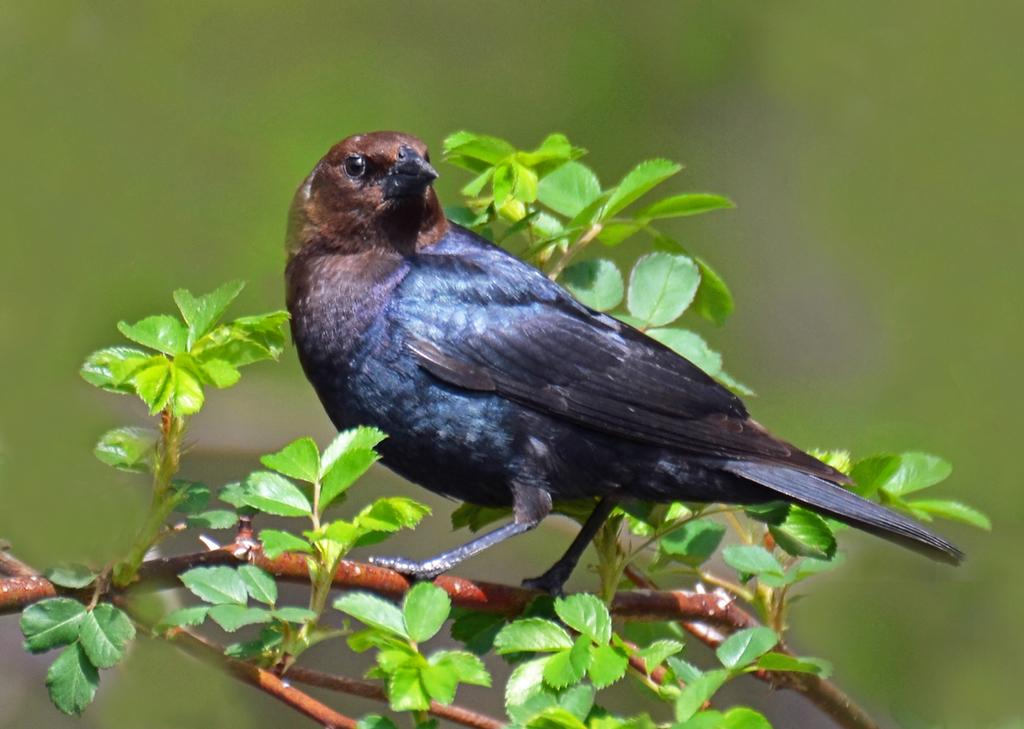What animal is present on a plant in the image? There is a crow on a plant in the image. What color are the leaves on the plant? The leaves visible in the image are green. How would you describe the background of the image? The background of the image appears blurry. What type of process is being carried out by the trucks in the image? There are no trucks present in the image, so no process can be observed. 